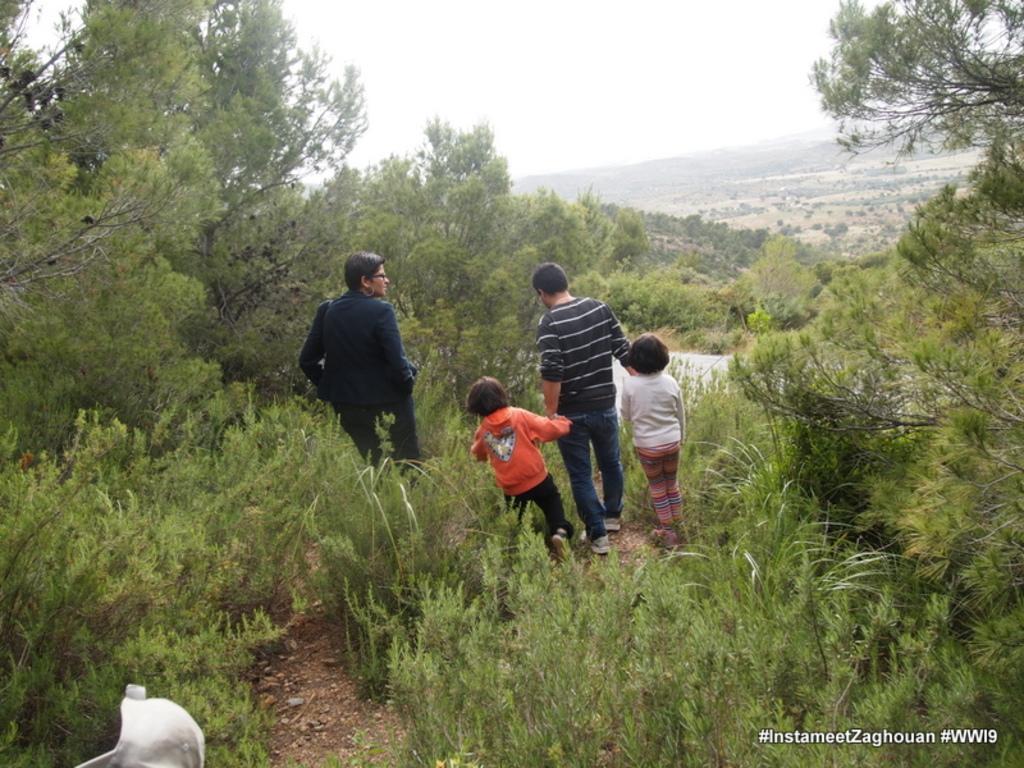Can you describe this image briefly? In this picture there are two persons and kids standing and there are few trees and plants around them and there are trees in the background and there is something written in the right bottom corner. 